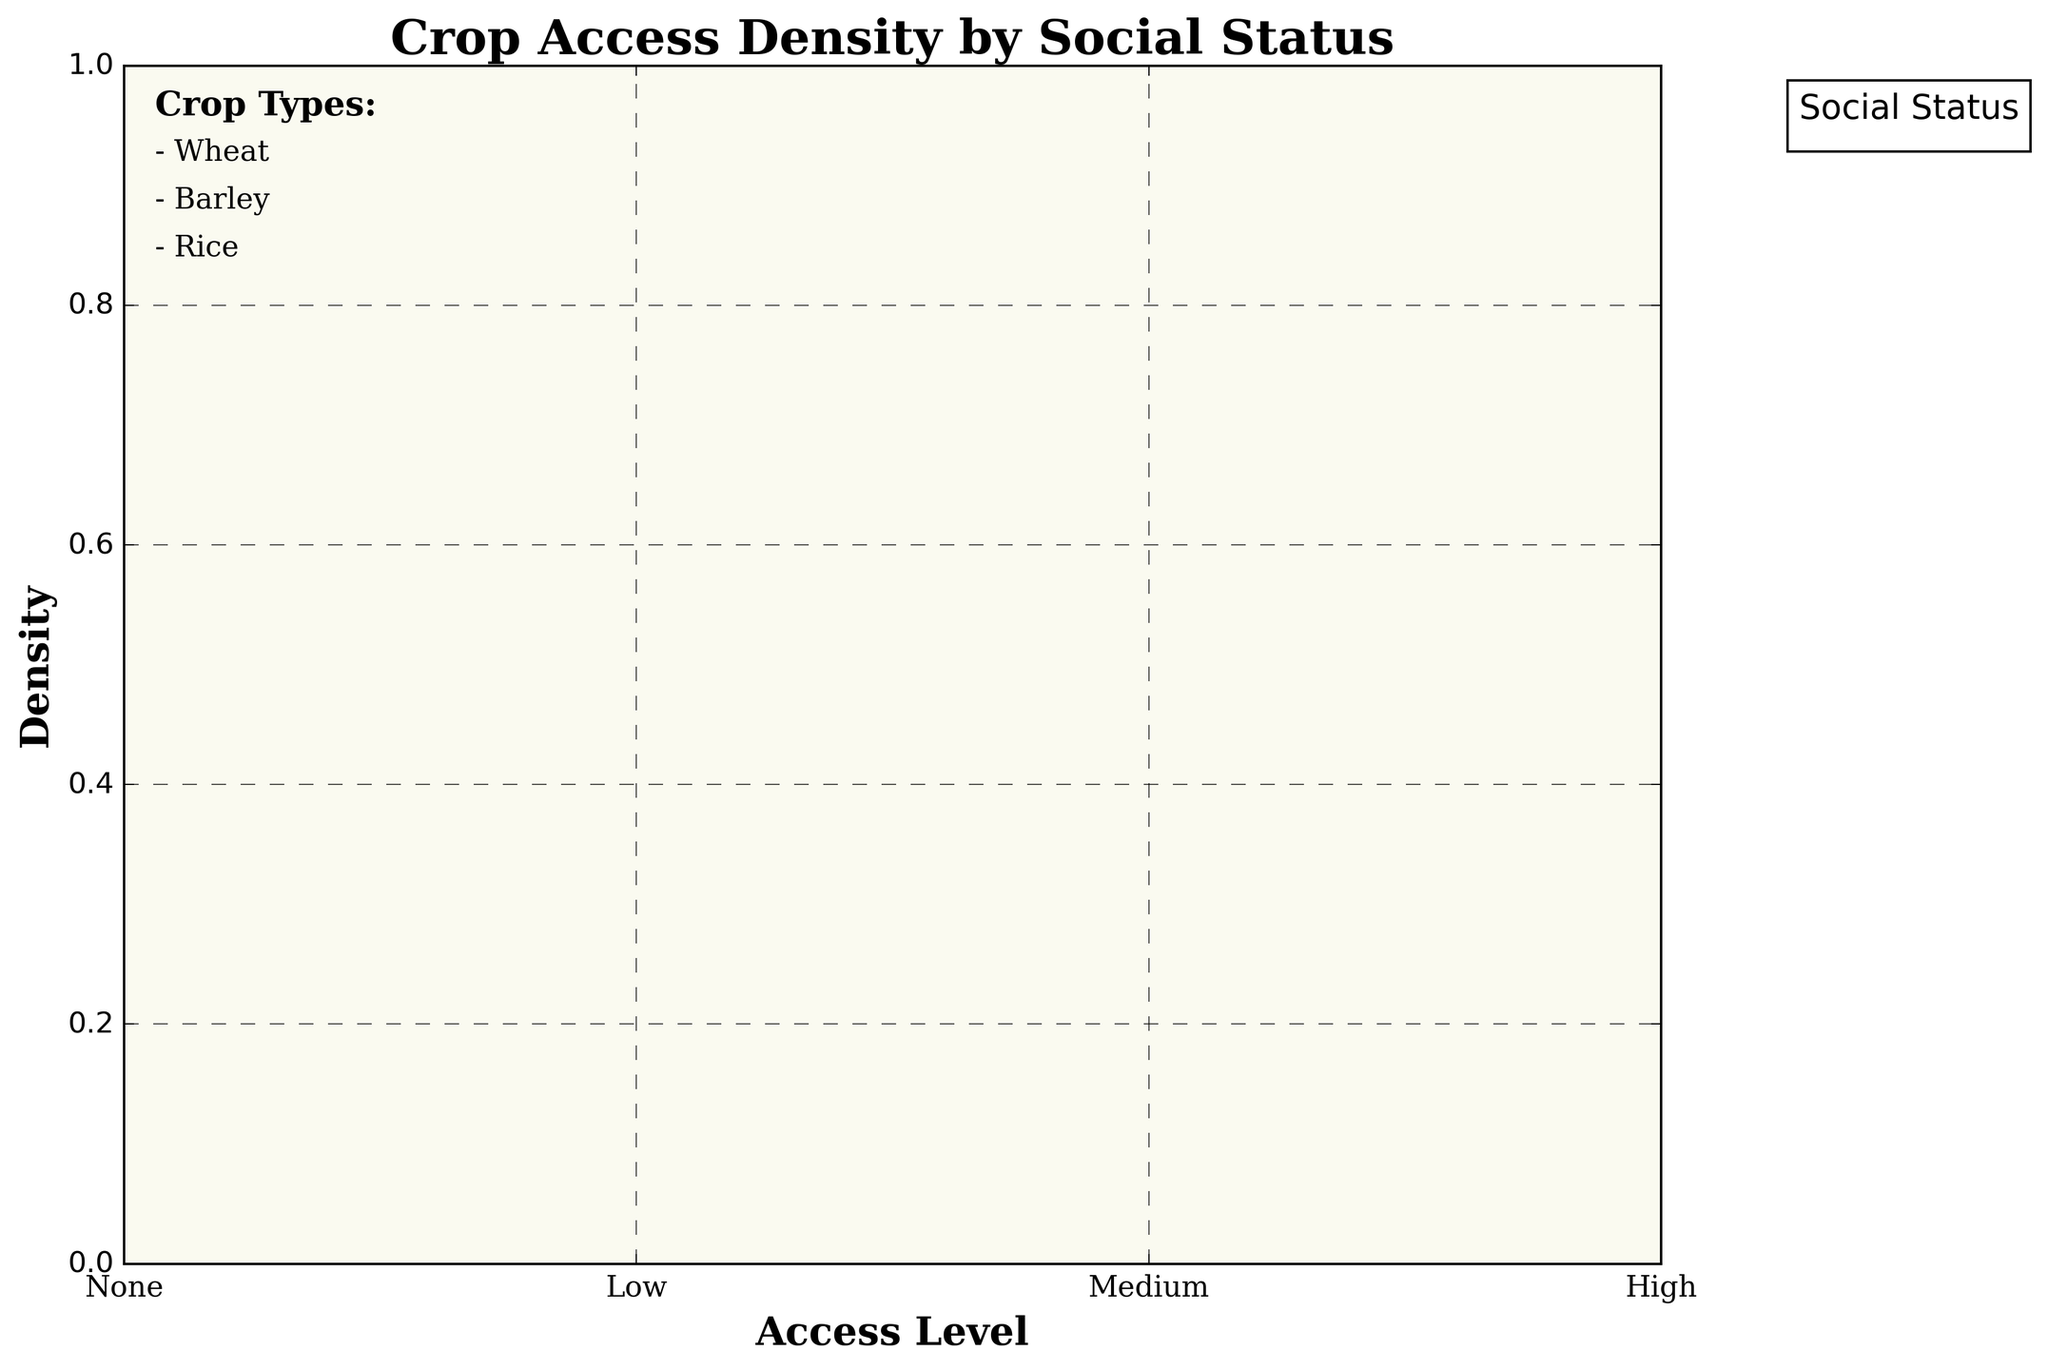What is the title of the plot? The title of the plot can be found at the top of the figure. It is usually defined to provide a quick understanding of what the plot is about.
Answer: Crop Access Density by Social Status What are the labels on the x-axis? The labels on the x-axis represent different access levels to crop types. These labels are typically found at the bottom of the plot.
Answer: None, Low, Medium, High Which social status group shows the highest density for Wheat access at the 'High' level? By observing the plot and focusing on the region corresponding to 'High' on the x-axis for Wheat, we can see which social status has the greatest density.
Answer: Royalty and Nobility How do access levels to Rice compare between Nobility and Peasants? By comparing the density lines for Nobility and Peasants along the access levels for Rice, we can see the relative densities.
Answer: Nobility has higher density at 'Medium' access while Peasants have higher density at 'Low' access Which crop type appears to have the least access for Slaves? Examine the density plot lines for Slaves across all crops. The crop with the lowest density for the highest access levels is the answer.
Answer: Wheat and Rice What is the general trend in access to Barley among Social Status groups? Observe the pattern of density for Barley across different social statuses. Higher social statuses should show higher densities at higher access levels.
Answer: Higher social statuses have greater access to Barley Do Merchants have any 'High' access level for any crop? Look at the density plot lines for Merchants to see if any line reaches 'High'.
Answer: No How does the density of access to Wheat for Artisans compare at 'Medium' and 'Low' levels? Compare the density lines for Artisans at the 'Medium' and 'Low' access levels for Wheat.
Answer: Higher at 'Low' level Are there any crops where all Social Status groups have access levels? If a crop has density plots for all social status groups at some access level, it indicates all groups have access.
Answer: Barley Which crop shows the most equal distribution across different social statuses at the 'Low' access level? By examining the density plots across different crops at the 'Low' access level, look for the crop where densities are more uniform.
Answer: Barley 